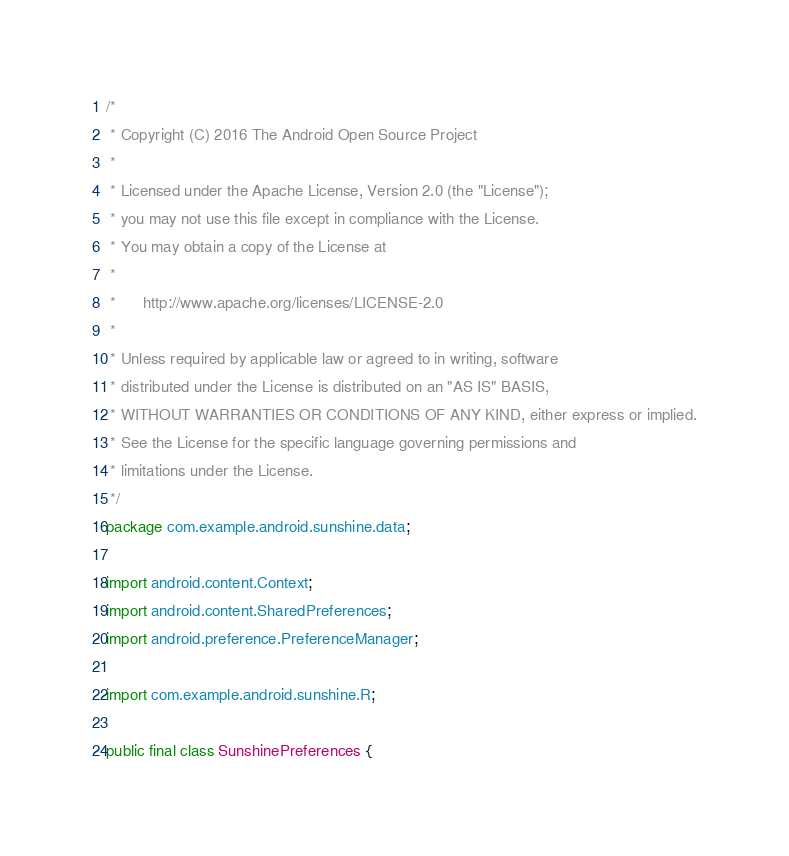<code> <loc_0><loc_0><loc_500><loc_500><_Java_>/*
 * Copyright (C) 2016 The Android Open Source Project
 *
 * Licensed under the Apache License, Version 2.0 (the "License");
 * you may not use this file except in compliance with the License.
 * You may obtain a copy of the License at
 *
 *      http://www.apache.org/licenses/LICENSE-2.0
 *
 * Unless required by applicable law or agreed to in writing, software
 * distributed under the License is distributed on an "AS IS" BASIS,
 * WITHOUT WARRANTIES OR CONDITIONS OF ANY KIND, either express or implied.
 * See the License for the specific language governing permissions and
 * limitations under the License.
 */
package com.example.android.sunshine.data;

import android.content.Context;
import android.content.SharedPreferences;
import android.preference.PreferenceManager;

import com.example.android.sunshine.R;

public final class SunshinePreferences {
</code> 